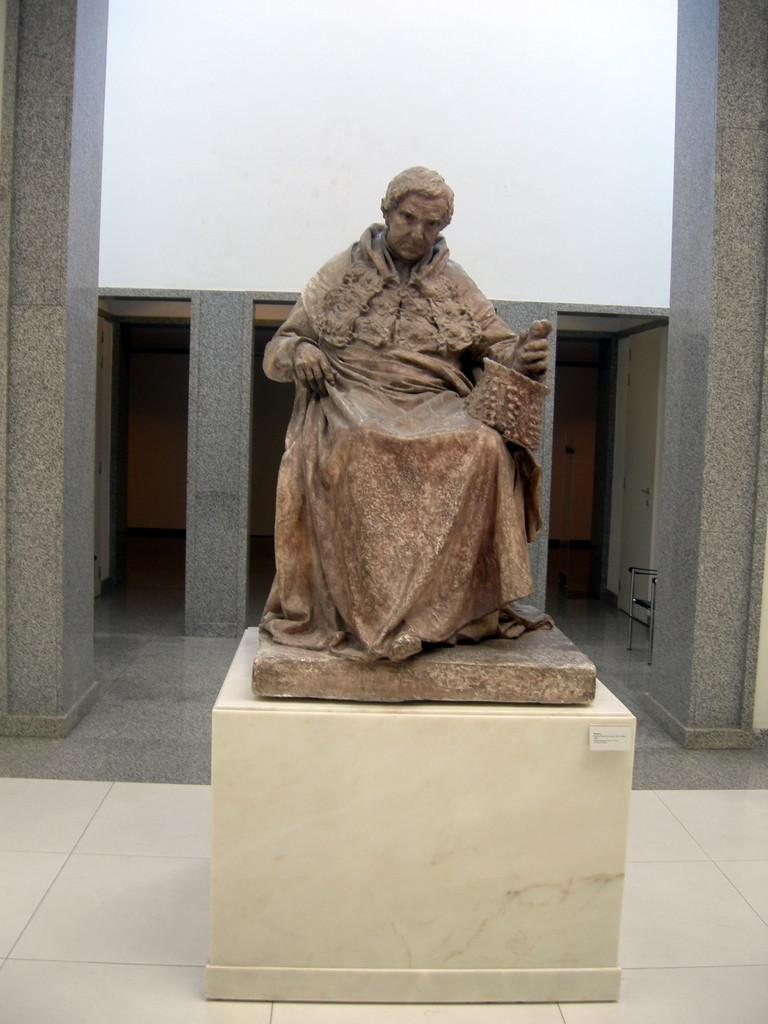What is the main subject of the image? There is a sculpture of a person sitting in the image. What can be observed about the sculpture's attire? The sculpture is wearing clothes. What is the sculpture holding in its hand? The sculpture is holding an object in its hand. What architectural features are visible in the image? There are doors and a chair visible in the image. What type of material is the wall made of? The wall is made of marble. What is the surface beneath the sculpture? There is a floor in the image. What type of quiver is the sculpture using to store its arrows in the image? There is no quiver or arrows present in the image; the sculpture is holding an object, but it is not an arrow or quiver. 